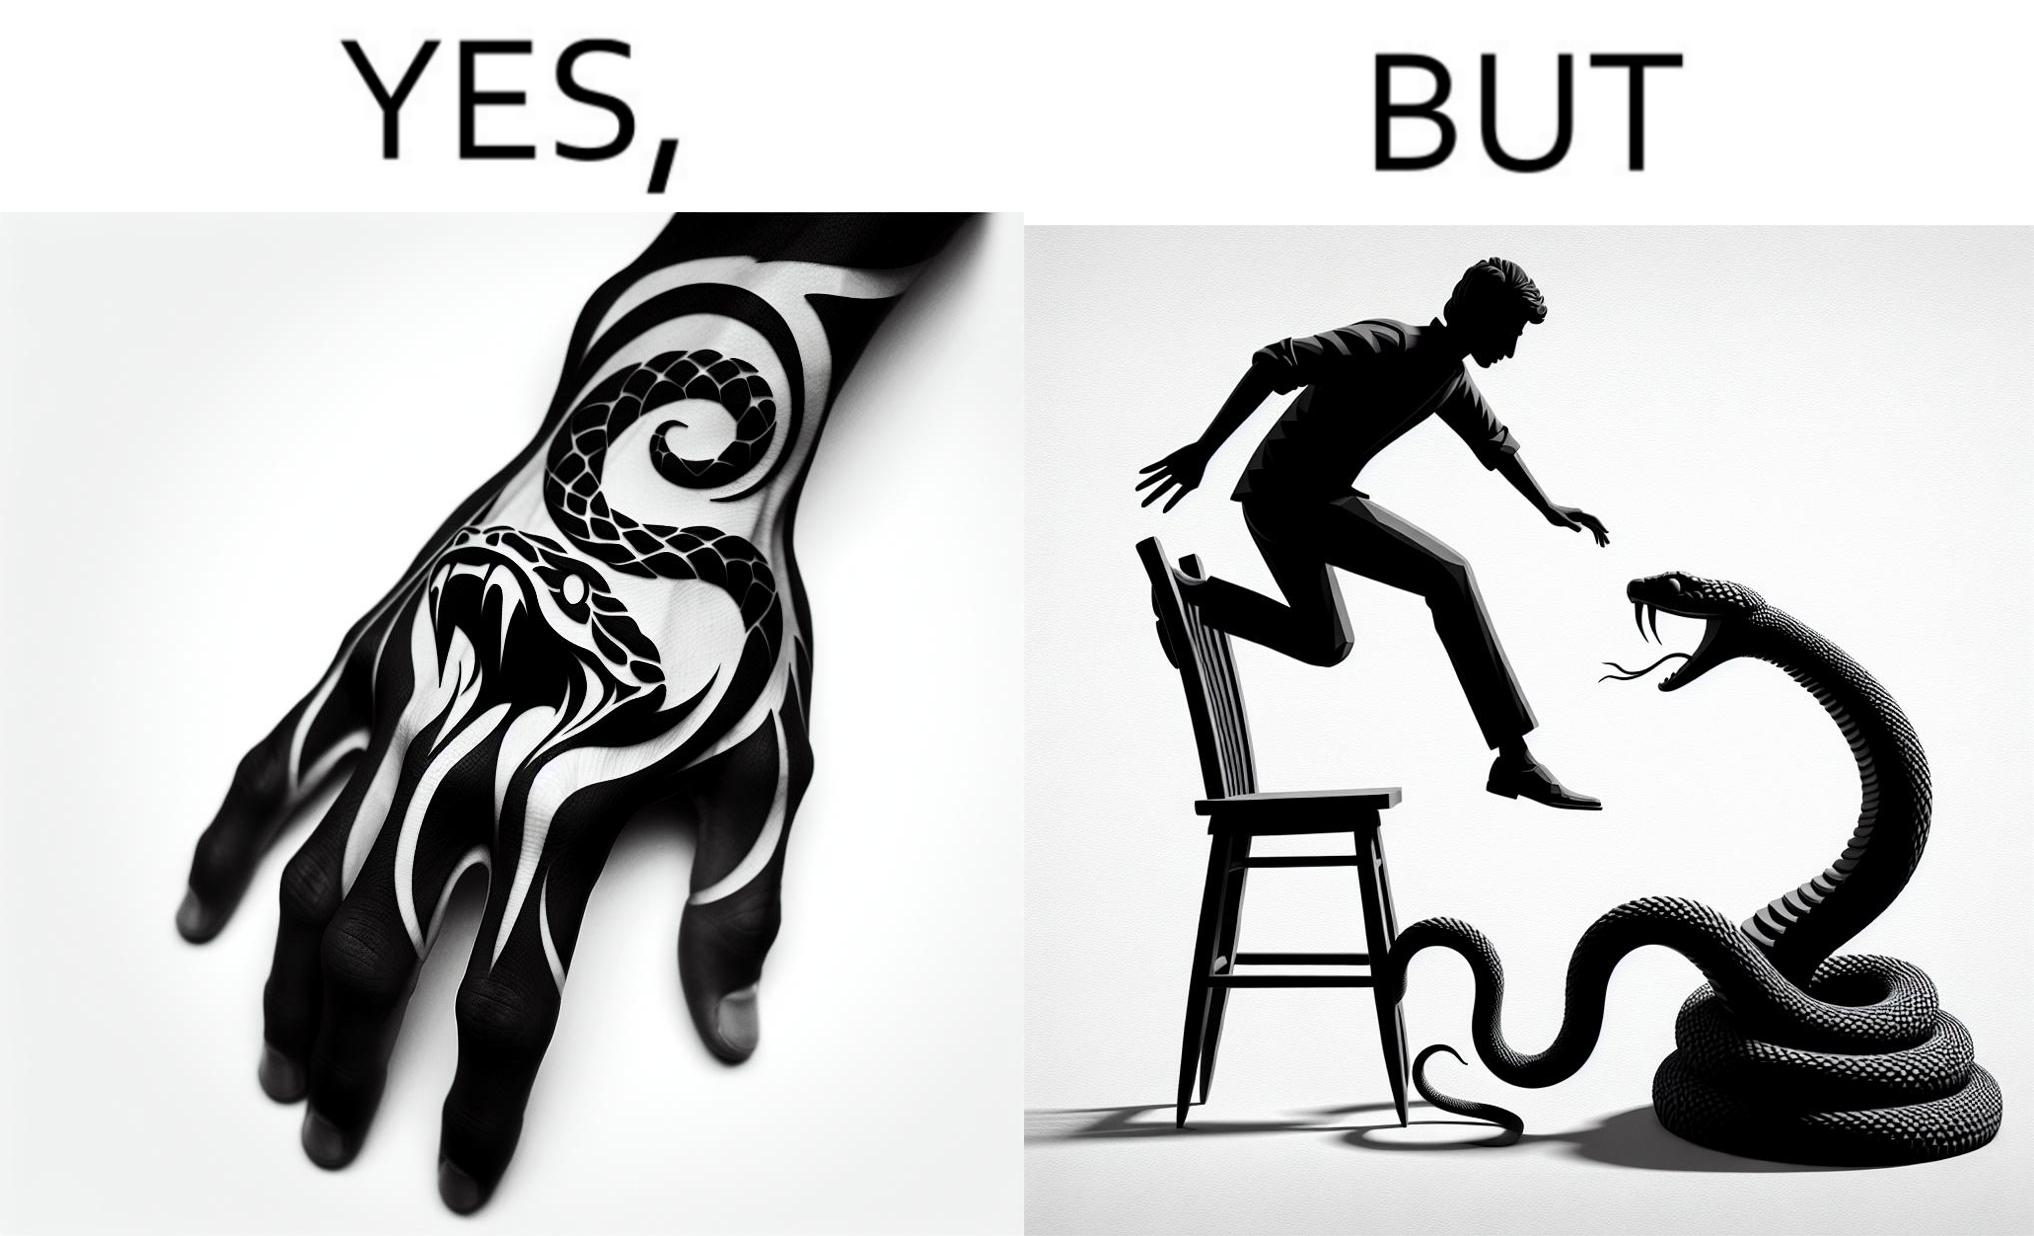What is shown in this image? The image is ironic, because in the first image the tattoo of a snake on someone's hand may give us a hint about how powerful or brave the person can be who is having this tattoo but in the second image the person with same tattoo is seen frightened due to a snake in his house 